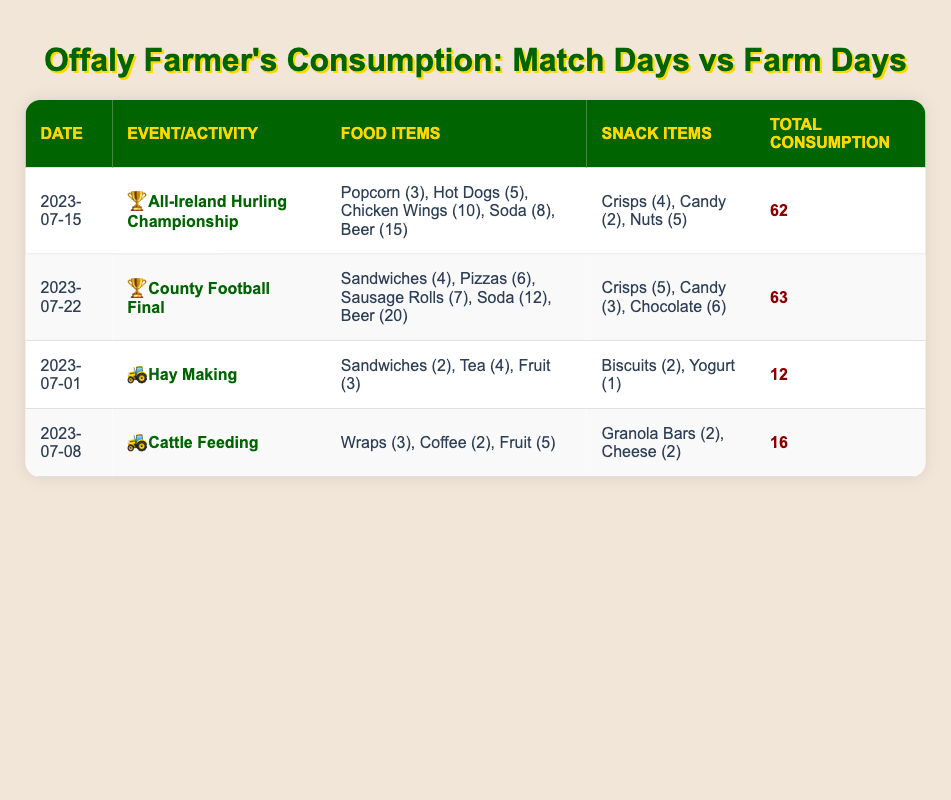What was the total consumption during the All-Ireland Hurling Championship? The table shows that the total consumption for the All-Ireland Hurling Championship on July 15, 2023, is listed in the last column as 62.
Answer: 62 How many different types of food items were consumed during the County Football Final? The County Football Final has five types of food items listed: sandwiches, pizzas, sausage rolls, soda, and beer.
Answer: 5 Was more total consumption recorded during match events compared to regular farm days? For match events, the total consumption was 62 (Hurling Championship) + 63 (County Football Final) = 125. For regular farm days, total consumption was 12 (Hay Making) + 16 (Cattle Feeding) = 28. Comparing these, 125 > 28, thus more total consumption was indeed recorded during match events.
Answer: Yes What is the average total consumption for all match events? The two match events have total consumptions of 62 and 63. To find the average, sum them: 62 + 63 = 125, and then divide by 2: 125 / 2 = 62.5.
Answer: 62.5 Which event had a higher total consumption: the All-Ireland Hurling Championship or Hay Making? The All-Ireland Hurling Championship had a total consumption of 62, while Hay Making had a total consumption of 12. Since 62 is greater than 12, the Hurling Championship had a higher total consumption.
Answer: All-Ireland Hurling Championship What is the difference in total consumption between the County Football Final and Cattle Feeding? The total consumption for the County Football Final is 63, and for Cattle Feeding, it is 16. The difference is 63 - 16 = 47.
Answer: 47 How many types of snack items were consumed during the All-Ireland Hurling Championship? The snack items listed for the All-Ireland Hurling Championship include crisps, candy, and nuts, totaling three types of snack items.
Answer: 3 Is it true that the total consumption for regular farming activities was more than for any match event? To verify this, we compare the sums: the maximum total consumption of match events is 63 (County Football Final), against regular farming activities' total of 28 (12 + 16). Since 28 is less than 63, it is not true that regular farming activities had more consumption.
Answer: No 